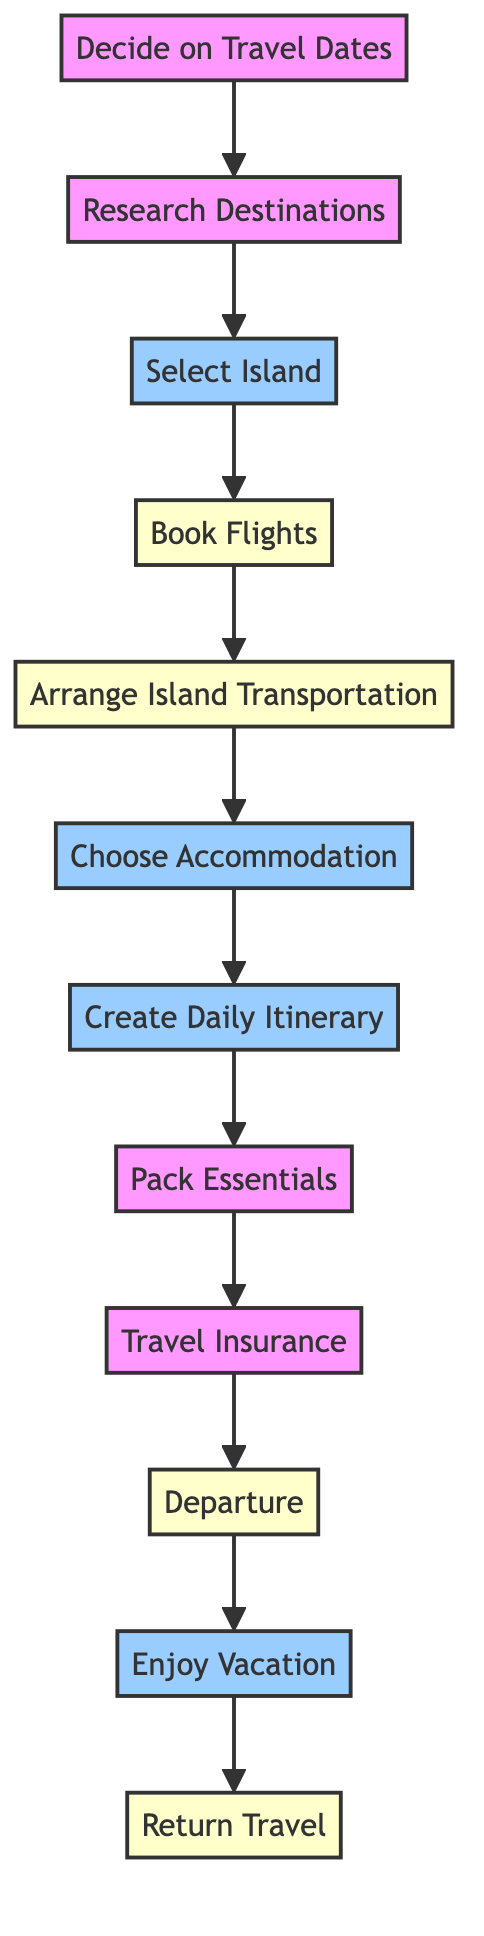What is the first step in the itinerary? The diagram shows that the first step is "Decide on Travel Dates." This is connected directly to the starting point of the flowchart.
Answer: Decide on Travel Dates How many nodes are in the diagram? By counting the elements listed in the flowchart, there are a total of 12 nodes representing different steps in the itinerary planning.
Answer: 12 What comes immediately after booking flights? The diagram indicates that after "Book Flights," the next step is "Arrange Island Transportation." This follows directly in the flow of the chart.
Answer: Arrange Island Transportation Which steps involve island activities? The steps "Select Island," "Choose Accommodation," "Create Daily Itinerary," and "Enjoy Vacation" all engage with island-specific activities and choices, as indicated by the island-specific styling in the flowchart.
Answer: Select Island, Choose Accommodation, Create Daily Itinerary, Enjoy Vacation If you skip "Travel Insurance," which step would you go directly to? According to the flowchart, if "Travel Insurance" is skipped, the next step would be "Departure," as it is the next node directly connected after "Travel Insurance."
Answer: Departure What is the relationship between "Enjoy Vacation" and "Return Travel"? The diagram shows a direct connection from "Enjoy Vacation" leading to "Return Travel," indicating that enjoying the vacation leads to the process of returning home.
Answer: Direct connection How many steps occur before "Departure"? There are 9 steps that take place before reaching "Departure." They include all the preceding tasks from the first step "Decide on Travel Dates" through "Travel Insurance."
Answer: 9 What type of insurance is recommended in the itinerary? The step explicitly mentions the need for "Travel Insurance," specified as important to cover unforeseen events during the trip.
Answer: Travel Insurance What step involves planning daily activities? The step labeled "Create Daily Itinerary" specifically focuses on planning daily activities during the island stay, as shown in the flowchart.
Answer: Create Daily Itinerary 